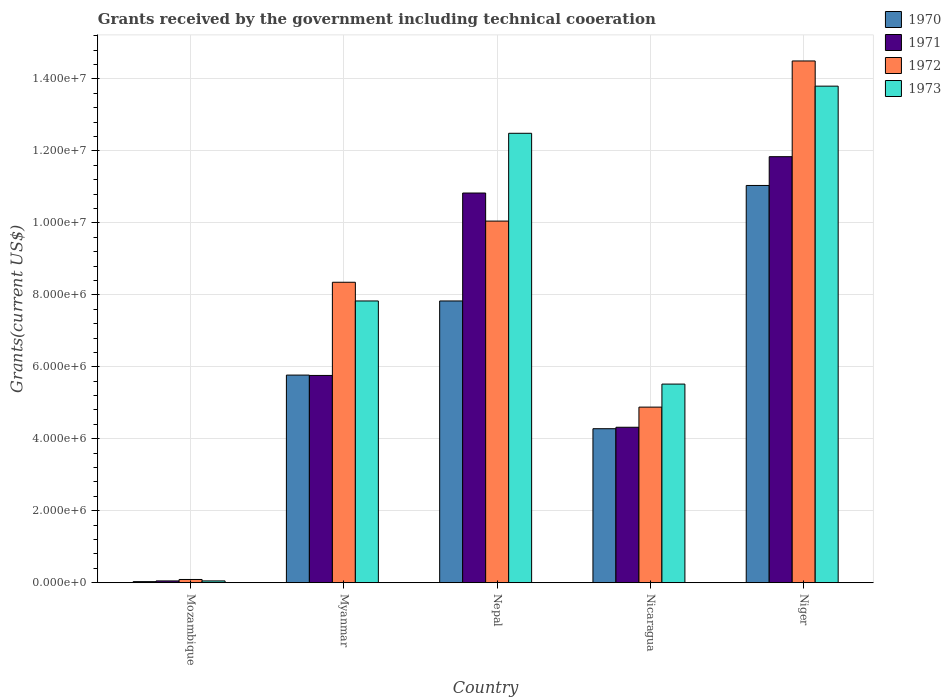Are the number of bars on each tick of the X-axis equal?
Provide a short and direct response. Yes. How many bars are there on the 4th tick from the right?
Offer a very short reply. 4. What is the label of the 3rd group of bars from the left?
Offer a very short reply. Nepal. What is the total grants received by the government in 1970 in Niger?
Ensure brevity in your answer.  1.10e+07. Across all countries, what is the maximum total grants received by the government in 1971?
Your response must be concise. 1.18e+07. Across all countries, what is the minimum total grants received by the government in 1973?
Your answer should be compact. 5.00e+04. In which country was the total grants received by the government in 1970 maximum?
Make the answer very short. Niger. In which country was the total grants received by the government in 1972 minimum?
Offer a terse response. Mozambique. What is the total total grants received by the government in 1971 in the graph?
Provide a short and direct response. 3.28e+07. What is the difference between the total grants received by the government in 1973 in Myanmar and that in Niger?
Give a very brief answer. -5.97e+06. What is the difference between the total grants received by the government in 1973 in Nepal and the total grants received by the government in 1971 in Mozambique?
Your answer should be very brief. 1.24e+07. What is the average total grants received by the government in 1973 per country?
Make the answer very short. 7.94e+06. What is the difference between the total grants received by the government of/in 1973 and total grants received by the government of/in 1970 in Mozambique?
Your answer should be very brief. 2.00e+04. What is the ratio of the total grants received by the government in 1972 in Mozambique to that in Myanmar?
Provide a succinct answer. 0.01. Is the total grants received by the government in 1971 in Myanmar less than that in Nepal?
Ensure brevity in your answer.  Yes. What is the difference between the highest and the second highest total grants received by the government in 1972?
Offer a very short reply. 6.15e+06. What is the difference between the highest and the lowest total grants received by the government in 1972?
Ensure brevity in your answer.  1.44e+07. Is the sum of the total grants received by the government in 1971 in Mozambique and Nepal greater than the maximum total grants received by the government in 1973 across all countries?
Offer a very short reply. No. What does the 3rd bar from the left in Mozambique represents?
Ensure brevity in your answer.  1972. Is it the case that in every country, the sum of the total grants received by the government in 1972 and total grants received by the government in 1973 is greater than the total grants received by the government in 1971?
Provide a succinct answer. Yes. Are all the bars in the graph horizontal?
Your answer should be very brief. No. How many countries are there in the graph?
Offer a very short reply. 5. Are the values on the major ticks of Y-axis written in scientific E-notation?
Give a very brief answer. Yes. Does the graph contain any zero values?
Keep it short and to the point. No. Does the graph contain grids?
Provide a succinct answer. Yes. Where does the legend appear in the graph?
Provide a short and direct response. Top right. What is the title of the graph?
Your response must be concise. Grants received by the government including technical cooeration. What is the label or title of the Y-axis?
Your response must be concise. Grants(current US$). What is the Grants(current US$) in 1970 in Mozambique?
Keep it short and to the point. 3.00e+04. What is the Grants(current US$) of 1971 in Mozambique?
Your answer should be compact. 5.00e+04. What is the Grants(current US$) of 1972 in Mozambique?
Your answer should be compact. 9.00e+04. What is the Grants(current US$) in 1973 in Mozambique?
Provide a short and direct response. 5.00e+04. What is the Grants(current US$) of 1970 in Myanmar?
Your response must be concise. 5.77e+06. What is the Grants(current US$) of 1971 in Myanmar?
Offer a very short reply. 5.76e+06. What is the Grants(current US$) in 1972 in Myanmar?
Your answer should be very brief. 8.35e+06. What is the Grants(current US$) in 1973 in Myanmar?
Keep it short and to the point. 7.83e+06. What is the Grants(current US$) of 1970 in Nepal?
Give a very brief answer. 7.83e+06. What is the Grants(current US$) of 1971 in Nepal?
Provide a succinct answer. 1.08e+07. What is the Grants(current US$) of 1972 in Nepal?
Your answer should be compact. 1.00e+07. What is the Grants(current US$) in 1973 in Nepal?
Provide a succinct answer. 1.25e+07. What is the Grants(current US$) of 1970 in Nicaragua?
Provide a short and direct response. 4.28e+06. What is the Grants(current US$) of 1971 in Nicaragua?
Keep it short and to the point. 4.32e+06. What is the Grants(current US$) of 1972 in Nicaragua?
Keep it short and to the point. 4.88e+06. What is the Grants(current US$) of 1973 in Nicaragua?
Ensure brevity in your answer.  5.52e+06. What is the Grants(current US$) in 1970 in Niger?
Your answer should be compact. 1.10e+07. What is the Grants(current US$) in 1971 in Niger?
Keep it short and to the point. 1.18e+07. What is the Grants(current US$) in 1972 in Niger?
Your answer should be very brief. 1.45e+07. What is the Grants(current US$) in 1973 in Niger?
Give a very brief answer. 1.38e+07. Across all countries, what is the maximum Grants(current US$) in 1970?
Make the answer very short. 1.10e+07. Across all countries, what is the maximum Grants(current US$) of 1971?
Offer a terse response. 1.18e+07. Across all countries, what is the maximum Grants(current US$) in 1972?
Your answer should be very brief. 1.45e+07. Across all countries, what is the maximum Grants(current US$) in 1973?
Provide a short and direct response. 1.38e+07. Across all countries, what is the minimum Grants(current US$) in 1972?
Your answer should be very brief. 9.00e+04. What is the total Grants(current US$) in 1970 in the graph?
Keep it short and to the point. 2.90e+07. What is the total Grants(current US$) in 1971 in the graph?
Your response must be concise. 3.28e+07. What is the total Grants(current US$) in 1972 in the graph?
Give a very brief answer. 3.79e+07. What is the total Grants(current US$) of 1973 in the graph?
Give a very brief answer. 3.97e+07. What is the difference between the Grants(current US$) in 1970 in Mozambique and that in Myanmar?
Your answer should be compact. -5.74e+06. What is the difference between the Grants(current US$) of 1971 in Mozambique and that in Myanmar?
Keep it short and to the point. -5.71e+06. What is the difference between the Grants(current US$) of 1972 in Mozambique and that in Myanmar?
Make the answer very short. -8.26e+06. What is the difference between the Grants(current US$) in 1973 in Mozambique and that in Myanmar?
Keep it short and to the point. -7.78e+06. What is the difference between the Grants(current US$) of 1970 in Mozambique and that in Nepal?
Make the answer very short. -7.80e+06. What is the difference between the Grants(current US$) in 1971 in Mozambique and that in Nepal?
Provide a succinct answer. -1.08e+07. What is the difference between the Grants(current US$) of 1972 in Mozambique and that in Nepal?
Give a very brief answer. -9.96e+06. What is the difference between the Grants(current US$) in 1973 in Mozambique and that in Nepal?
Offer a terse response. -1.24e+07. What is the difference between the Grants(current US$) of 1970 in Mozambique and that in Nicaragua?
Your answer should be very brief. -4.25e+06. What is the difference between the Grants(current US$) in 1971 in Mozambique and that in Nicaragua?
Your answer should be compact. -4.27e+06. What is the difference between the Grants(current US$) in 1972 in Mozambique and that in Nicaragua?
Ensure brevity in your answer.  -4.79e+06. What is the difference between the Grants(current US$) of 1973 in Mozambique and that in Nicaragua?
Offer a terse response. -5.47e+06. What is the difference between the Grants(current US$) in 1970 in Mozambique and that in Niger?
Provide a succinct answer. -1.10e+07. What is the difference between the Grants(current US$) of 1971 in Mozambique and that in Niger?
Your answer should be compact. -1.18e+07. What is the difference between the Grants(current US$) of 1972 in Mozambique and that in Niger?
Provide a short and direct response. -1.44e+07. What is the difference between the Grants(current US$) in 1973 in Mozambique and that in Niger?
Make the answer very short. -1.38e+07. What is the difference between the Grants(current US$) of 1970 in Myanmar and that in Nepal?
Your response must be concise. -2.06e+06. What is the difference between the Grants(current US$) in 1971 in Myanmar and that in Nepal?
Your response must be concise. -5.07e+06. What is the difference between the Grants(current US$) of 1972 in Myanmar and that in Nepal?
Provide a short and direct response. -1.70e+06. What is the difference between the Grants(current US$) in 1973 in Myanmar and that in Nepal?
Provide a succinct answer. -4.66e+06. What is the difference between the Grants(current US$) of 1970 in Myanmar and that in Nicaragua?
Your answer should be very brief. 1.49e+06. What is the difference between the Grants(current US$) in 1971 in Myanmar and that in Nicaragua?
Offer a terse response. 1.44e+06. What is the difference between the Grants(current US$) in 1972 in Myanmar and that in Nicaragua?
Offer a terse response. 3.47e+06. What is the difference between the Grants(current US$) of 1973 in Myanmar and that in Nicaragua?
Your answer should be very brief. 2.31e+06. What is the difference between the Grants(current US$) in 1970 in Myanmar and that in Niger?
Your answer should be compact. -5.27e+06. What is the difference between the Grants(current US$) in 1971 in Myanmar and that in Niger?
Give a very brief answer. -6.08e+06. What is the difference between the Grants(current US$) of 1972 in Myanmar and that in Niger?
Offer a very short reply. -6.15e+06. What is the difference between the Grants(current US$) in 1973 in Myanmar and that in Niger?
Your response must be concise. -5.97e+06. What is the difference between the Grants(current US$) in 1970 in Nepal and that in Nicaragua?
Provide a short and direct response. 3.55e+06. What is the difference between the Grants(current US$) in 1971 in Nepal and that in Nicaragua?
Provide a succinct answer. 6.51e+06. What is the difference between the Grants(current US$) in 1972 in Nepal and that in Nicaragua?
Your answer should be very brief. 5.17e+06. What is the difference between the Grants(current US$) of 1973 in Nepal and that in Nicaragua?
Your response must be concise. 6.97e+06. What is the difference between the Grants(current US$) of 1970 in Nepal and that in Niger?
Make the answer very short. -3.21e+06. What is the difference between the Grants(current US$) of 1971 in Nepal and that in Niger?
Ensure brevity in your answer.  -1.01e+06. What is the difference between the Grants(current US$) of 1972 in Nepal and that in Niger?
Your answer should be compact. -4.45e+06. What is the difference between the Grants(current US$) of 1973 in Nepal and that in Niger?
Offer a terse response. -1.31e+06. What is the difference between the Grants(current US$) of 1970 in Nicaragua and that in Niger?
Offer a terse response. -6.76e+06. What is the difference between the Grants(current US$) of 1971 in Nicaragua and that in Niger?
Give a very brief answer. -7.52e+06. What is the difference between the Grants(current US$) of 1972 in Nicaragua and that in Niger?
Your answer should be compact. -9.62e+06. What is the difference between the Grants(current US$) in 1973 in Nicaragua and that in Niger?
Keep it short and to the point. -8.28e+06. What is the difference between the Grants(current US$) of 1970 in Mozambique and the Grants(current US$) of 1971 in Myanmar?
Provide a short and direct response. -5.73e+06. What is the difference between the Grants(current US$) of 1970 in Mozambique and the Grants(current US$) of 1972 in Myanmar?
Offer a terse response. -8.32e+06. What is the difference between the Grants(current US$) of 1970 in Mozambique and the Grants(current US$) of 1973 in Myanmar?
Give a very brief answer. -7.80e+06. What is the difference between the Grants(current US$) in 1971 in Mozambique and the Grants(current US$) in 1972 in Myanmar?
Offer a terse response. -8.30e+06. What is the difference between the Grants(current US$) of 1971 in Mozambique and the Grants(current US$) of 1973 in Myanmar?
Make the answer very short. -7.78e+06. What is the difference between the Grants(current US$) in 1972 in Mozambique and the Grants(current US$) in 1973 in Myanmar?
Give a very brief answer. -7.74e+06. What is the difference between the Grants(current US$) in 1970 in Mozambique and the Grants(current US$) in 1971 in Nepal?
Offer a terse response. -1.08e+07. What is the difference between the Grants(current US$) of 1970 in Mozambique and the Grants(current US$) of 1972 in Nepal?
Your answer should be very brief. -1.00e+07. What is the difference between the Grants(current US$) of 1970 in Mozambique and the Grants(current US$) of 1973 in Nepal?
Ensure brevity in your answer.  -1.25e+07. What is the difference between the Grants(current US$) of 1971 in Mozambique and the Grants(current US$) of 1972 in Nepal?
Make the answer very short. -1.00e+07. What is the difference between the Grants(current US$) in 1971 in Mozambique and the Grants(current US$) in 1973 in Nepal?
Your response must be concise. -1.24e+07. What is the difference between the Grants(current US$) of 1972 in Mozambique and the Grants(current US$) of 1973 in Nepal?
Offer a terse response. -1.24e+07. What is the difference between the Grants(current US$) in 1970 in Mozambique and the Grants(current US$) in 1971 in Nicaragua?
Make the answer very short. -4.29e+06. What is the difference between the Grants(current US$) of 1970 in Mozambique and the Grants(current US$) of 1972 in Nicaragua?
Make the answer very short. -4.85e+06. What is the difference between the Grants(current US$) in 1970 in Mozambique and the Grants(current US$) in 1973 in Nicaragua?
Your answer should be very brief. -5.49e+06. What is the difference between the Grants(current US$) of 1971 in Mozambique and the Grants(current US$) of 1972 in Nicaragua?
Ensure brevity in your answer.  -4.83e+06. What is the difference between the Grants(current US$) of 1971 in Mozambique and the Grants(current US$) of 1973 in Nicaragua?
Your answer should be very brief. -5.47e+06. What is the difference between the Grants(current US$) in 1972 in Mozambique and the Grants(current US$) in 1973 in Nicaragua?
Give a very brief answer. -5.43e+06. What is the difference between the Grants(current US$) of 1970 in Mozambique and the Grants(current US$) of 1971 in Niger?
Provide a succinct answer. -1.18e+07. What is the difference between the Grants(current US$) in 1970 in Mozambique and the Grants(current US$) in 1972 in Niger?
Offer a terse response. -1.45e+07. What is the difference between the Grants(current US$) of 1970 in Mozambique and the Grants(current US$) of 1973 in Niger?
Offer a terse response. -1.38e+07. What is the difference between the Grants(current US$) in 1971 in Mozambique and the Grants(current US$) in 1972 in Niger?
Offer a very short reply. -1.44e+07. What is the difference between the Grants(current US$) in 1971 in Mozambique and the Grants(current US$) in 1973 in Niger?
Offer a very short reply. -1.38e+07. What is the difference between the Grants(current US$) of 1972 in Mozambique and the Grants(current US$) of 1973 in Niger?
Your answer should be compact. -1.37e+07. What is the difference between the Grants(current US$) of 1970 in Myanmar and the Grants(current US$) of 1971 in Nepal?
Your response must be concise. -5.06e+06. What is the difference between the Grants(current US$) of 1970 in Myanmar and the Grants(current US$) of 1972 in Nepal?
Your response must be concise. -4.28e+06. What is the difference between the Grants(current US$) in 1970 in Myanmar and the Grants(current US$) in 1973 in Nepal?
Give a very brief answer. -6.72e+06. What is the difference between the Grants(current US$) of 1971 in Myanmar and the Grants(current US$) of 1972 in Nepal?
Ensure brevity in your answer.  -4.29e+06. What is the difference between the Grants(current US$) in 1971 in Myanmar and the Grants(current US$) in 1973 in Nepal?
Ensure brevity in your answer.  -6.73e+06. What is the difference between the Grants(current US$) of 1972 in Myanmar and the Grants(current US$) of 1973 in Nepal?
Keep it short and to the point. -4.14e+06. What is the difference between the Grants(current US$) of 1970 in Myanmar and the Grants(current US$) of 1971 in Nicaragua?
Your response must be concise. 1.45e+06. What is the difference between the Grants(current US$) in 1970 in Myanmar and the Grants(current US$) in 1972 in Nicaragua?
Ensure brevity in your answer.  8.90e+05. What is the difference between the Grants(current US$) of 1971 in Myanmar and the Grants(current US$) of 1972 in Nicaragua?
Keep it short and to the point. 8.80e+05. What is the difference between the Grants(current US$) in 1972 in Myanmar and the Grants(current US$) in 1973 in Nicaragua?
Provide a short and direct response. 2.83e+06. What is the difference between the Grants(current US$) of 1970 in Myanmar and the Grants(current US$) of 1971 in Niger?
Ensure brevity in your answer.  -6.07e+06. What is the difference between the Grants(current US$) of 1970 in Myanmar and the Grants(current US$) of 1972 in Niger?
Keep it short and to the point. -8.73e+06. What is the difference between the Grants(current US$) of 1970 in Myanmar and the Grants(current US$) of 1973 in Niger?
Your answer should be very brief. -8.03e+06. What is the difference between the Grants(current US$) of 1971 in Myanmar and the Grants(current US$) of 1972 in Niger?
Provide a short and direct response. -8.74e+06. What is the difference between the Grants(current US$) in 1971 in Myanmar and the Grants(current US$) in 1973 in Niger?
Offer a terse response. -8.04e+06. What is the difference between the Grants(current US$) in 1972 in Myanmar and the Grants(current US$) in 1973 in Niger?
Provide a short and direct response. -5.45e+06. What is the difference between the Grants(current US$) in 1970 in Nepal and the Grants(current US$) in 1971 in Nicaragua?
Your answer should be compact. 3.51e+06. What is the difference between the Grants(current US$) of 1970 in Nepal and the Grants(current US$) of 1972 in Nicaragua?
Offer a terse response. 2.95e+06. What is the difference between the Grants(current US$) in 1970 in Nepal and the Grants(current US$) in 1973 in Nicaragua?
Make the answer very short. 2.31e+06. What is the difference between the Grants(current US$) of 1971 in Nepal and the Grants(current US$) of 1972 in Nicaragua?
Your answer should be compact. 5.95e+06. What is the difference between the Grants(current US$) of 1971 in Nepal and the Grants(current US$) of 1973 in Nicaragua?
Offer a very short reply. 5.31e+06. What is the difference between the Grants(current US$) of 1972 in Nepal and the Grants(current US$) of 1973 in Nicaragua?
Your answer should be compact. 4.53e+06. What is the difference between the Grants(current US$) of 1970 in Nepal and the Grants(current US$) of 1971 in Niger?
Give a very brief answer. -4.01e+06. What is the difference between the Grants(current US$) of 1970 in Nepal and the Grants(current US$) of 1972 in Niger?
Make the answer very short. -6.67e+06. What is the difference between the Grants(current US$) in 1970 in Nepal and the Grants(current US$) in 1973 in Niger?
Your answer should be compact. -5.97e+06. What is the difference between the Grants(current US$) of 1971 in Nepal and the Grants(current US$) of 1972 in Niger?
Your answer should be very brief. -3.67e+06. What is the difference between the Grants(current US$) in 1971 in Nepal and the Grants(current US$) in 1973 in Niger?
Your answer should be very brief. -2.97e+06. What is the difference between the Grants(current US$) of 1972 in Nepal and the Grants(current US$) of 1973 in Niger?
Your answer should be very brief. -3.75e+06. What is the difference between the Grants(current US$) in 1970 in Nicaragua and the Grants(current US$) in 1971 in Niger?
Make the answer very short. -7.56e+06. What is the difference between the Grants(current US$) of 1970 in Nicaragua and the Grants(current US$) of 1972 in Niger?
Provide a succinct answer. -1.02e+07. What is the difference between the Grants(current US$) in 1970 in Nicaragua and the Grants(current US$) in 1973 in Niger?
Make the answer very short. -9.52e+06. What is the difference between the Grants(current US$) in 1971 in Nicaragua and the Grants(current US$) in 1972 in Niger?
Keep it short and to the point. -1.02e+07. What is the difference between the Grants(current US$) of 1971 in Nicaragua and the Grants(current US$) of 1973 in Niger?
Give a very brief answer. -9.48e+06. What is the difference between the Grants(current US$) in 1972 in Nicaragua and the Grants(current US$) in 1973 in Niger?
Ensure brevity in your answer.  -8.92e+06. What is the average Grants(current US$) in 1970 per country?
Keep it short and to the point. 5.79e+06. What is the average Grants(current US$) in 1971 per country?
Offer a terse response. 6.56e+06. What is the average Grants(current US$) of 1972 per country?
Your response must be concise. 7.57e+06. What is the average Grants(current US$) of 1973 per country?
Keep it short and to the point. 7.94e+06. What is the difference between the Grants(current US$) in 1970 and Grants(current US$) in 1973 in Mozambique?
Offer a terse response. -2.00e+04. What is the difference between the Grants(current US$) in 1971 and Grants(current US$) in 1972 in Mozambique?
Give a very brief answer. -4.00e+04. What is the difference between the Grants(current US$) of 1970 and Grants(current US$) of 1971 in Myanmar?
Keep it short and to the point. 10000. What is the difference between the Grants(current US$) in 1970 and Grants(current US$) in 1972 in Myanmar?
Offer a very short reply. -2.58e+06. What is the difference between the Grants(current US$) in 1970 and Grants(current US$) in 1973 in Myanmar?
Provide a short and direct response. -2.06e+06. What is the difference between the Grants(current US$) of 1971 and Grants(current US$) of 1972 in Myanmar?
Provide a short and direct response. -2.59e+06. What is the difference between the Grants(current US$) in 1971 and Grants(current US$) in 1973 in Myanmar?
Make the answer very short. -2.07e+06. What is the difference between the Grants(current US$) in 1972 and Grants(current US$) in 1973 in Myanmar?
Provide a short and direct response. 5.20e+05. What is the difference between the Grants(current US$) of 1970 and Grants(current US$) of 1972 in Nepal?
Your answer should be very brief. -2.22e+06. What is the difference between the Grants(current US$) in 1970 and Grants(current US$) in 1973 in Nepal?
Offer a very short reply. -4.66e+06. What is the difference between the Grants(current US$) in 1971 and Grants(current US$) in 1972 in Nepal?
Provide a short and direct response. 7.80e+05. What is the difference between the Grants(current US$) of 1971 and Grants(current US$) of 1973 in Nepal?
Ensure brevity in your answer.  -1.66e+06. What is the difference between the Grants(current US$) of 1972 and Grants(current US$) of 1973 in Nepal?
Offer a terse response. -2.44e+06. What is the difference between the Grants(current US$) of 1970 and Grants(current US$) of 1972 in Nicaragua?
Make the answer very short. -6.00e+05. What is the difference between the Grants(current US$) in 1970 and Grants(current US$) in 1973 in Nicaragua?
Give a very brief answer. -1.24e+06. What is the difference between the Grants(current US$) of 1971 and Grants(current US$) of 1972 in Nicaragua?
Give a very brief answer. -5.60e+05. What is the difference between the Grants(current US$) in 1971 and Grants(current US$) in 1973 in Nicaragua?
Give a very brief answer. -1.20e+06. What is the difference between the Grants(current US$) of 1972 and Grants(current US$) of 1973 in Nicaragua?
Your answer should be very brief. -6.40e+05. What is the difference between the Grants(current US$) of 1970 and Grants(current US$) of 1971 in Niger?
Make the answer very short. -8.00e+05. What is the difference between the Grants(current US$) of 1970 and Grants(current US$) of 1972 in Niger?
Your response must be concise. -3.46e+06. What is the difference between the Grants(current US$) of 1970 and Grants(current US$) of 1973 in Niger?
Your answer should be compact. -2.76e+06. What is the difference between the Grants(current US$) of 1971 and Grants(current US$) of 1972 in Niger?
Give a very brief answer. -2.66e+06. What is the difference between the Grants(current US$) in 1971 and Grants(current US$) in 1973 in Niger?
Your answer should be compact. -1.96e+06. What is the ratio of the Grants(current US$) of 1970 in Mozambique to that in Myanmar?
Your answer should be very brief. 0.01. What is the ratio of the Grants(current US$) of 1971 in Mozambique to that in Myanmar?
Your answer should be compact. 0.01. What is the ratio of the Grants(current US$) in 1972 in Mozambique to that in Myanmar?
Provide a short and direct response. 0.01. What is the ratio of the Grants(current US$) in 1973 in Mozambique to that in Myanmar?
Keep it short and to the point. 0.01. What is the ratio of the Grants(current US$) of 1970 in Mozambique to that in Nepal?
Offer a very short reply. 0. What is the ratio of the Grants(current US$) in 1971 in Mozambique to that in Nepal?
Give a very brief answer. 0. What is the ratio of the Grants(current US$) of 1972 in Mozambique to that in Nepal?
Provide a succinct answer. 0.01. What is the ratio of the Grants(current US$) in 1973 in Mozambique to that in Nepal?
Offer a very short reply. 0. What is the ratio of the Grants(current US$) in 1970 in Mozambique to that in Nicaragua?
Your response must be concise. 0.01. What is the ratio of the Grants(current US$) of 1971 in Mozambique to that in Nicaragua?
Give a very brief answer. 0.01. What is the ratio of the Grants(current US$) in 1972 in Mozambique to that in Nicaragua?
Keep it short and to the point. 0.02. What is the ratio of the Grants(current US$) in 1973 in Mozambique to that in Nicaragua?
Keep it short and to the point. 0.01. What is the ratio of the Grants(current US$) of 1970 in Mozambique to that in Niger?
Keep it short and to the point. 0. What is the ratio of the Grants(current US$) in 1971 in Mozambique to that in Niger?
Ensure brevity in your answer.  0. What is the ratio of the Grants(current US$) in 1972 in Mozambique to that in Niger?
Give a very brief answer. 0.01. What is the ratio of the Grants(current US$) in 1973 in Mozambique to that in Niger?
Provide a succinct answer. 0. What is the ratio of the Grants(current US$) of 1970 in Myanmar to that in Nepal?
Give a very brief answer. 0.74. What is the ratio of the Grants(current US$) in 1971 in Myanmar to that in Nepal?
Provide a short and direct response. 0.53. What is the ratio of the Grants(current US$) of 1972 in Myanmar to that in Nepal?
Provide a short and direct response. 0.83. What is the ratio of the Grants(current US$) of 1973 in Myanmar to that in Nepal?
Keep it short and to the point. 0.63. What is the ratio of the Grants(current US$) in 1970 in Myanmar to that in Nicaragua?
Ensure brevity in your answer.  1.35. What is the ratio of the Grants(current US$) in 1971 in Myanmar to that in Nicaragua?
Your response must be concise. 1.33. What is the ratio of the Grants(current US$) in 1972 in Myanmar to that in Nicaragua?
Offer a terse response. 1.71. What is the ratio of the Grants(current US$) of 1973 in Myanmar to that in Nicaragua?
Keep it short and to the point. 1.42. What is the ratio of the Grants(current US$) of 1970 in Myanmar to that in Niger?
Offer a terse response. 0.52. What is the ratio of the Grants(current US$) of 1971 in Myanmar to that in Niger?
Provide a short and direct response. 0.49. What is the ratio of the Grants(current US$) of 1972 in Myanmar to that in Niger?
Give a very brief answer. 0.58. What is the ratio of the Grants(current US$) in 1973 in Myanmar to that in Niger?
Your response must be concise. 0.57. What is the ratio of the Grants(current US$) in 1970 in Nepal to that in Nicaragua?
Offer a terse response. 1.83. What is the ratio of the Grants(current US$) in 1971 in Nepal to that in Nicaragua?
Offer a terse response. 2.51. What is the ratio of the Grants(current US$) of 1972 in Nepal to that in Nicaragua?
Ensure brevity in your answer.  2.06. What is the ratio of the Grants(current US$) in 1973 in Nepal to that in Nicaragua?
Provide a short and direct response. 2.26. What is the ratio of the Grants(current US$) in 1970 in Nepal to that in Niger?
Give a very brief answer. 0.71. What is the ratio of the Grants(current US$) in 1971 in Nepal to that in Niger?
Provide a short and direct response. 0.91. What is the ratio of the Grants(current US$) of 1972 in Nepal to that in Niger?
Make the answer very short. 0.69. What is the ratio of the Grants(current US$) in 1973 in Nepal to that in Niger?
Provide a succinct answer. 0.91. What is the ratio of the Grants(current US$) in 1970 in Nicaragua to that in Niger?
Offer a very short reply. 0.39. What is the ratio of the Grants(current US$) of 1971 in Nicaragua to that in Niger?
Ensure brevity in your answer.  0.36. What is the ratio of the Grants(current US$) in 1972 in Nicaragua to that in Niger?
Your answer should be compact. 0.34. What is the ratio of the Grants(current US$) in 1973 in Nicaragua to that in Niger?
Keep it short and to the point. 0.4. What is the difference between the highest and the second highest Grants(current US$) of 1970?
Offer a very short reply. 3.21e+06. What is the difference between the highest and the second highest Grants(current US$) in 1971?
Provide a short and direct response. 1.01e+06. What is the difference between the highest and the second highest Grants(current US$) of 1972?
Your answer should be compact. 4.45e+06. What is the difference between the highest and the second highest Grants(current US$) of 1973?
Your answer should be very brief. 1.31e+06. What is the difference between the highest and the lowest Grants(current US$) in 1970?
Offer a terse response. 1.10e+07. What is the difference between the highest and the lowest Grants(current US$) of 1971?
Offer a very short reply. 1.18e+07. What is the difference between the highest and the lowest Grants(current US$) in 1972?
Your response must be concise. 1.44e+07. What is the difference between the highest and the lowest Grants(current US$) of 1973?
Provide a short and direct response. 1.38e+07. 